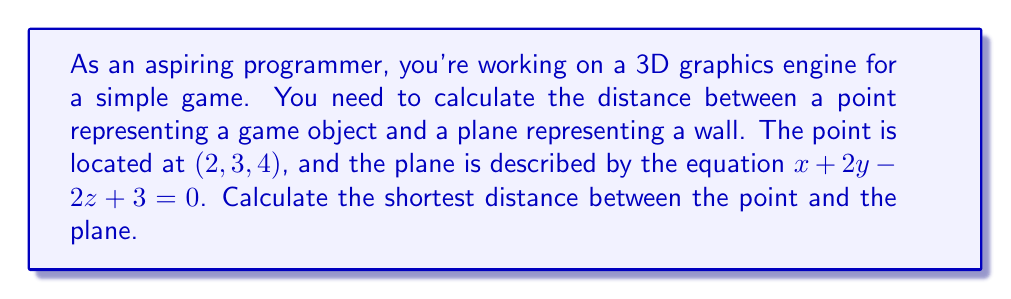Help me with this question. Let's approach this step-by-step:

1) The general equation for the distance $d$ from a point $(x_0, y_0, z_0)$ to a plane $ax + by + cz + d = 0$ is:

   $$d = \frac{|ax_0 + by_0 + cz_0 + d|}{\sqrt{a^2 + b^2 + c^2}}$$

2) In our case:
   - The point $(x_0, y_0, z_0)$ is $(2, 3, 4)$
   - The plane equation $x + 2y - 2z + 3 = 0$ gives us $a=1$, $b=2$, $c=-2$, and $d=3$

3) Let's substitute these values into our distance formula:

   $$d = \frac{|1(2) + 2(3) - 2(4) + 3|}{\sqrt{1^2 + 2^2 + (-2)^2}}$$

4) Simplify the numerator:
   $$d = \frac{|2 + 6 - 8 + 3|}{\sqrt{1 + 4 + 4}}$$
   $$d = \frac{|3|}{\sqrt{9}}$$

5) Simplify further:
   $$d = \frac{3}{3} = 1$$

Therefore, the shortest distance between the point (2, 3, 4) and the plane $x + 2y - 2z + 3 = 0$ is 1 unit.

This calculation is crucial in 3D graphics programming for collision detection, rendering optimizations, and other spatial computations.
Answer: $1$ unit 